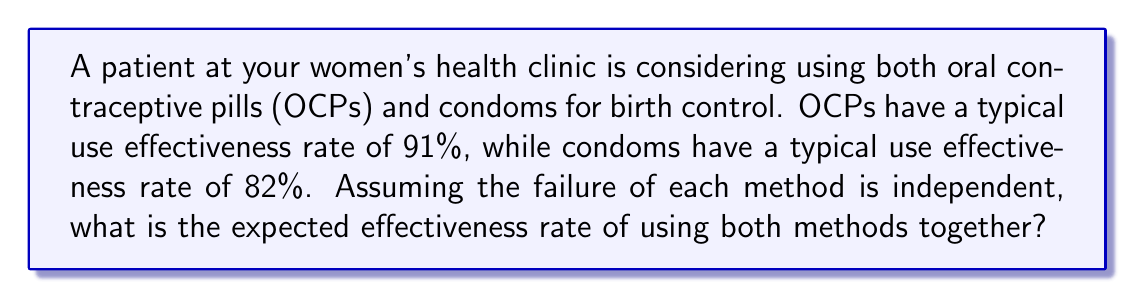Show me your answer to this math problem. To calculate the expected effectiveness rate of using both OCPs and condoms together, we need to follow these steps:

1. Convert the effectiveness rates to failure rates:
   OCP failure rate = 1 - 0.91 = 0.09 (9%)
   Condom failure rate = 1 - 0.82 = 0.18 (18%)

2. Calculate the probability of both methods failing simultaneously:
   $$P(\text{both fail}) = 0.09 \times 0.18 = 0.0162$$

3. Calculate the probability of at least one method working (i.e., not both failing):
   $$P(\text{at least one works}) = 1 - P(\text{both fail}) = 1 - 0.0162 = 0.9838$$

4. Convert the probability back to a percentage:
   $$0.9838 \times 100\% = 98.38\%$$

Therefore, the expected effectiveness rate of using both OCPs and condoms together is 98.38%.
Answer: 98.38% 